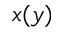Convert formula to latex. <formula><loc_0><loc_0><loc_500><loc_500>x ( y )</formula> 